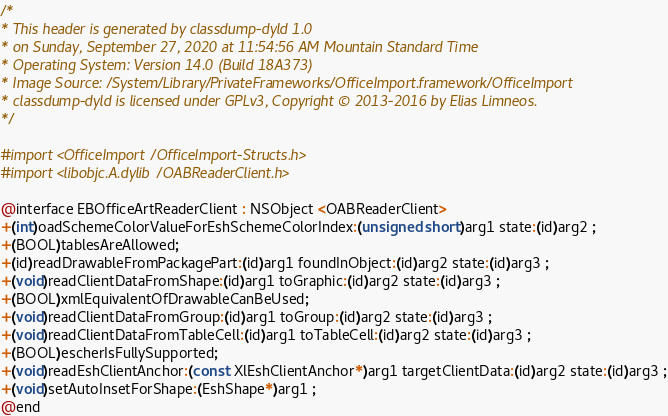<code> <loc_0><loc_0><loc_500><loc_500><_C_>/*
* This header is generated by classdump-dyld 1.0
* on Sunday, September 27, 2020 at 11:54:56 AM Mountain Standard Time
* Operating System: Version 14.0 (Build 18A373)
* Image Source: /System/Library/PrivateFrameworks/OfficeImport.framework/OfficeImport
* classdump-dyld is licensed under GPLv3, Copyright © 2013-2016 by Elias Limneos.
*/

#import <OfficeImport/OfficeImport-Structs.h>
#import <libobjc.A.dylib/OABReaderClient.h>

@interface EBOfficeArtReaderClient : NSObject <OABReaderClient>
+(int)oadSchemeColorValueForEshSchemeColorIndex:(unsigned short)arg1 state:(id)arg2 ;
+(BOOL)tablesAreAllowed;
+(id)readDrawableFromPackagePart:(id)arg1 foundInObject:(id)arg2 state:(id)arg3 ;
+(void)readClientDataFromShape:(id)arg1 toGraphic:(id)arg2 state:(id)arg3 ;
+(BOOL)xmlEquivalentOfDrawableCanBeUsed;
+(void)readClientDataFromGroup:(id)arg1 toGroup:(id)arg2 state:(id)arg3 ;
+(void)readClientDataFromTableCell:(id)arg1 toTableCell:(id)arg2 state:(id)arg3 ;
+(BOOL)escherIsFullySupported;
+(void)readEshClientAnchor:(const XlEshClientAnchor*)arg1 targetClientData:(id)arg2 state:(id)arg3 ;
+(void)setAutoInsetForShape:(EshShape*)arg1 ;
@end

</code> 